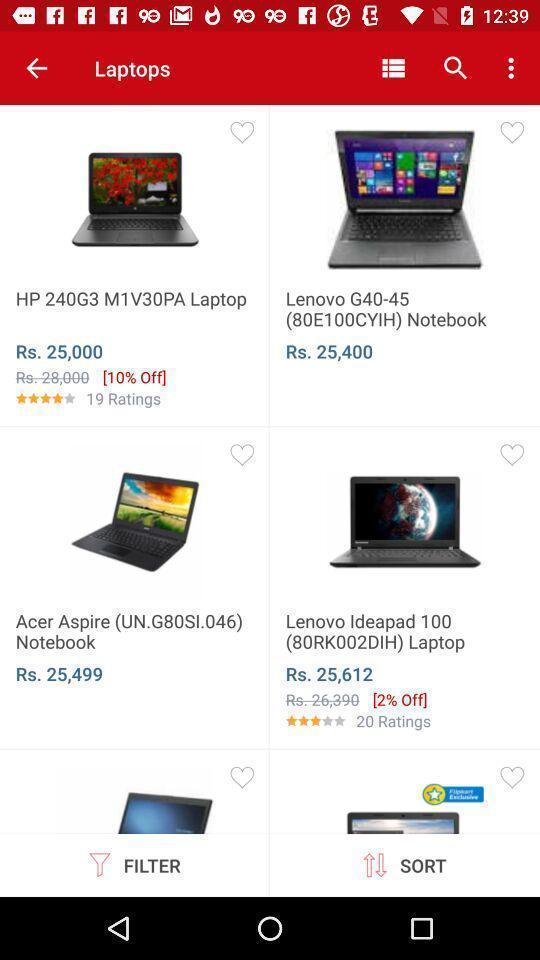Provide a detailed account of this screenshot. Screen displaying a shopping app. 